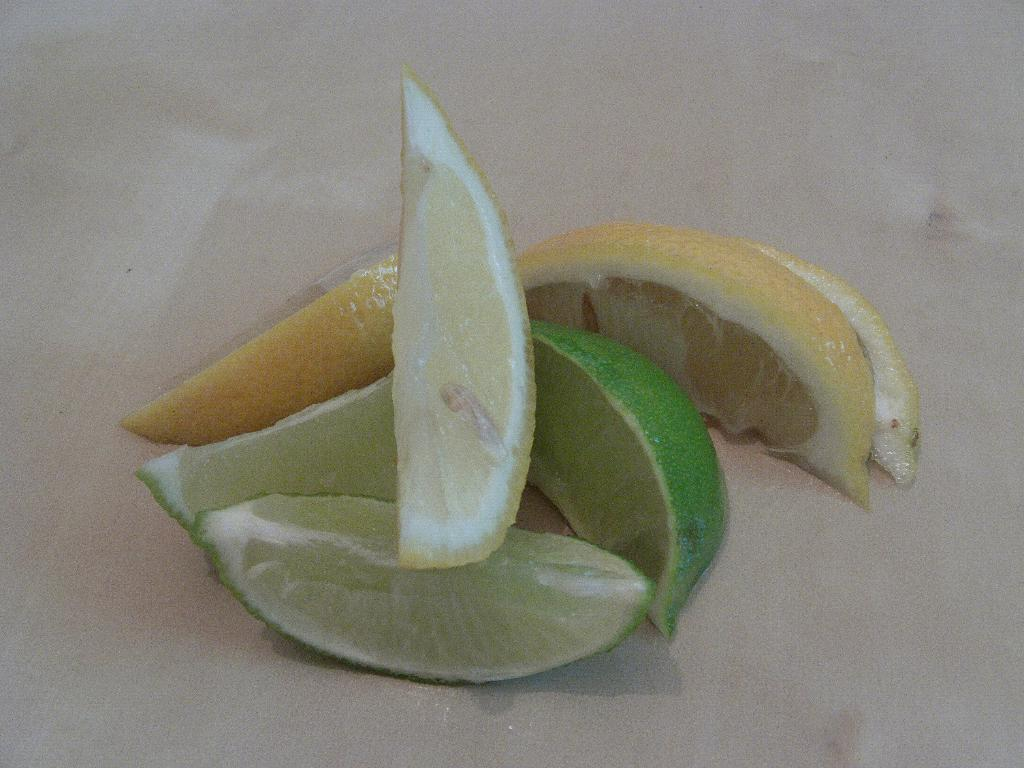What is the main object in the center of the image? There is a table in the center of the image. What is placed on the table? There are orange slices on the table. Where is the alley located in the image? There is no alley present in the image. What type of ring can be seen on the orange slices? There are no rings present on the orange slices in the image. 